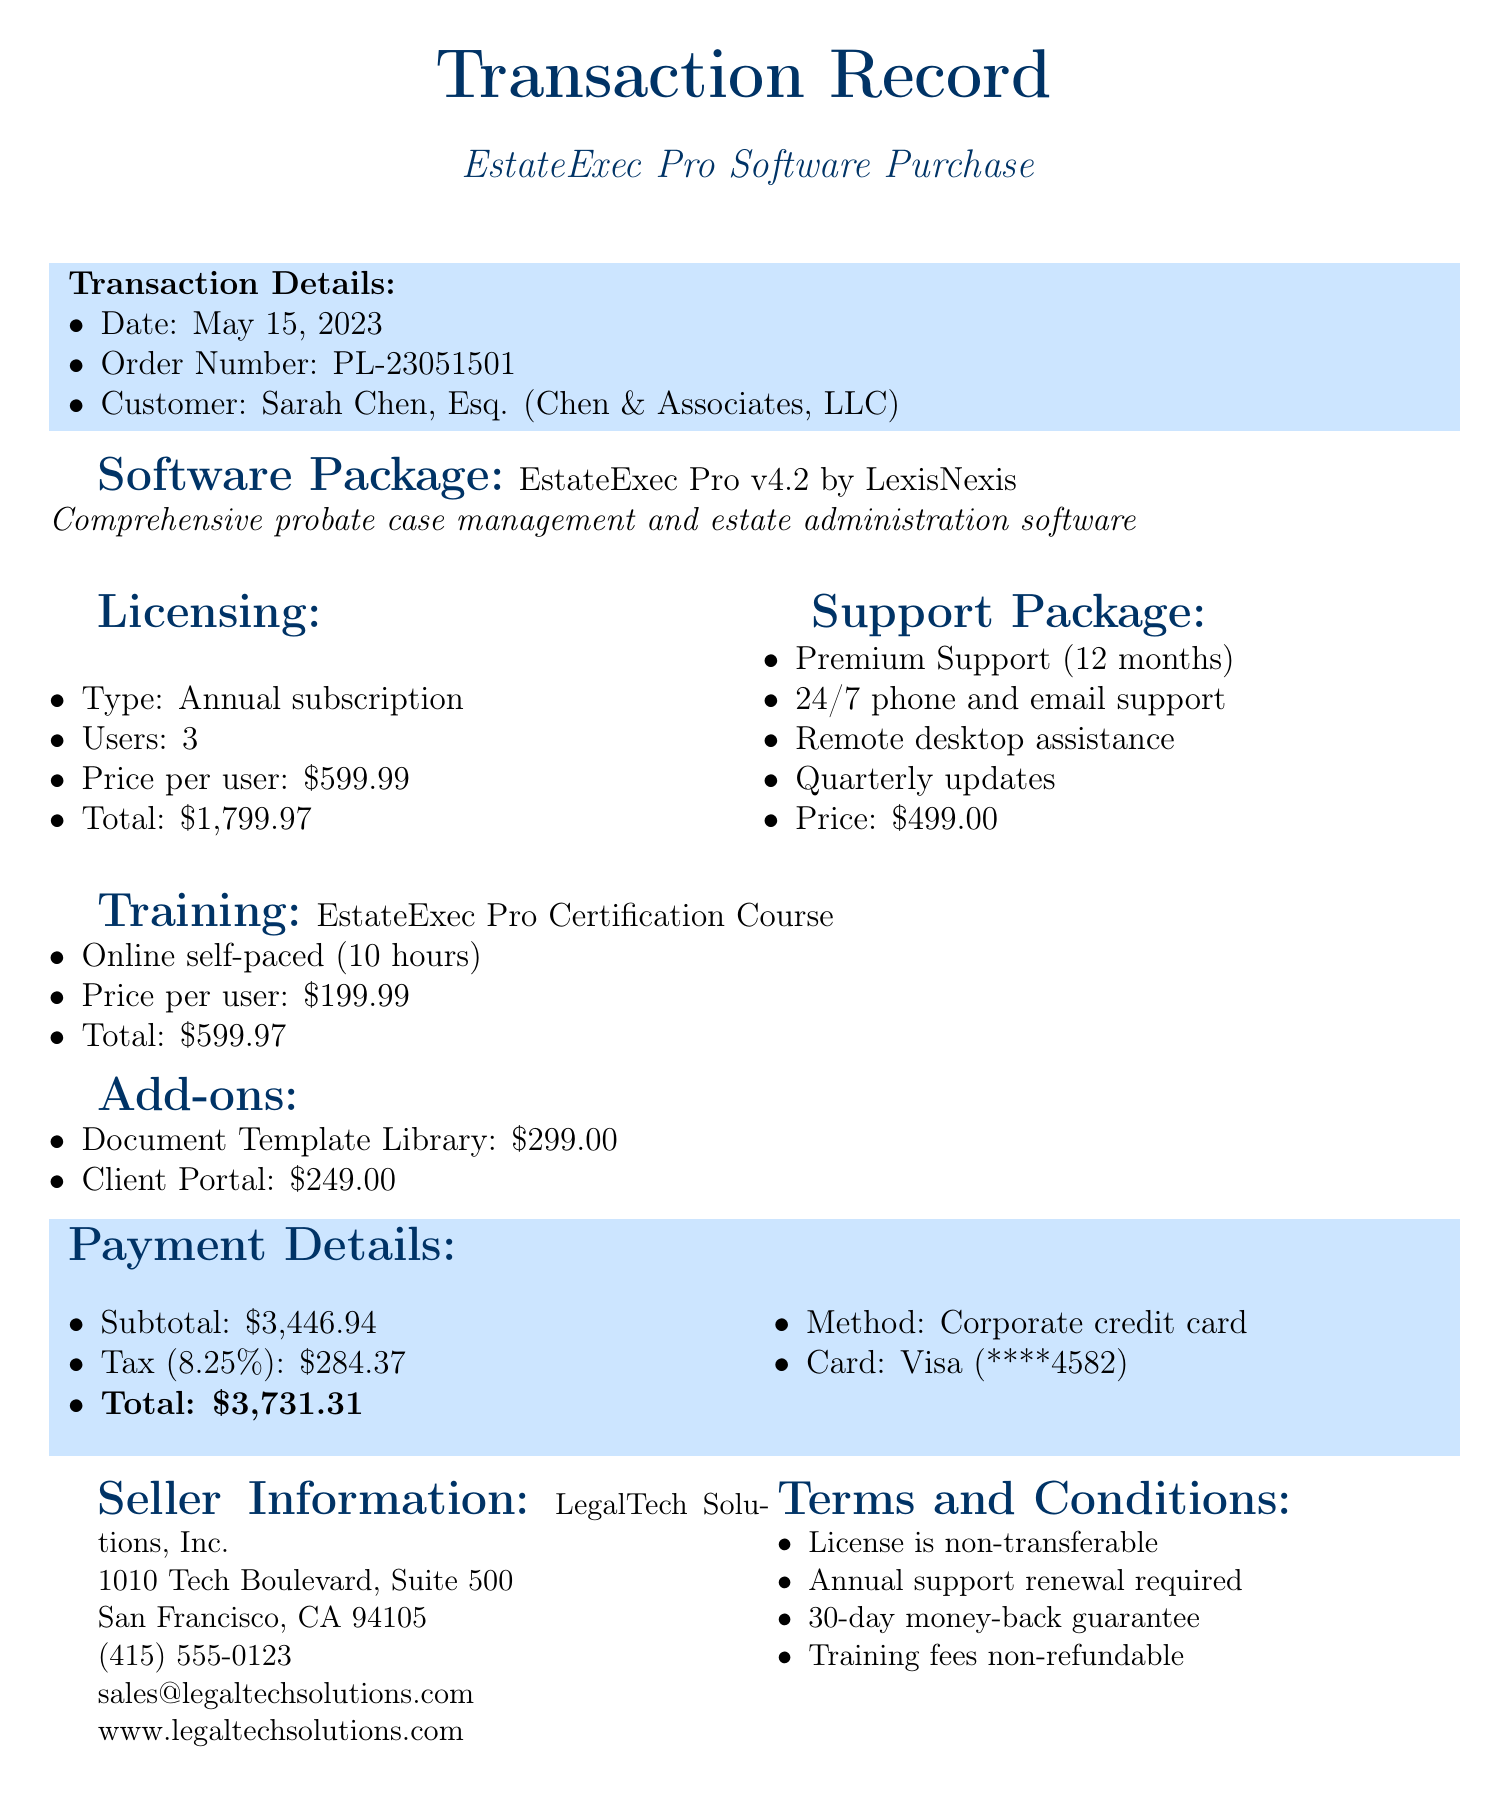What is the date of the transaction? The date of the transaction is provided in the document, which states May 15, 2023.
Answer: May 15, 2023 Who is the customer? The customer is mentioned in the transaction details section as Sarah Chen, Esq.
Answer: Sarah Chen, Esq What is the total licensing fee? The total licensing fee is clearly stated in the licensing section of the document as $1,799.97.
Answer: $1,799.97 What is included in the Premium Support feature? The document lists the features of the Premium Support package which include 24/7 phone and email support, remote desktop assistance, and quarterly software updates.
Answer: 24/7 phone and email support, remote desktop assistance, quarterly software updates What is the total cost including tax? The total cost is calculated as the sum of the subtotal and the tax amount provided in the payment details section.
Answer: $3,731.31 How many users does the licensing cover? The licensing details in the document specify that it covers 3 users.
Answer: 3 What is the price of the Document Template Library add-on? The add-on pricing is provided, showing that the Document Template Library is priced at $299.00.
Answer: $299.00 What type of transaction document is this? This document is a transaction record specifically for the purchase of probate law software.
Answer: Transaction Record What is the card type used for payment? The payment section of the document indicates that a Visa card was used.
Answer: Visa 